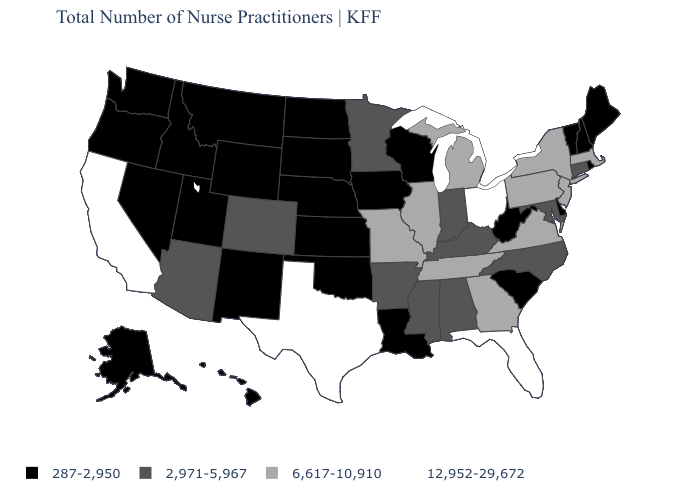What is the value of Indiana?
Short answer required. 2,971-5,967. Name the states that have a value in the range 12,952-29,672?
Be succinct. California, Florida, Ohio, Texas. What is the value of West Virginia?
Write a very short answer. 287-2,950. What is the value of Idaho?
Quick response, please. 287-2,950. Does Florida have the highest value in the USA?
Keep it brief. Yes. Is the legend a continuous bar?
Short answer required. No. Does the first symbol in the legend represent the smallest category?
Be succinct. Yes. Name the states that have a value in the range 287-2,950?
Quick response, please. Alaska, Delaware, Hawaii, Idaho, Iowa, Kansas, Louisiana, Maine, Montana, Nebraska, Nevada, New Hampshire, New Mexico, North Dakota, Oklahoma, Oregon, Rhode Island, South Carolina, South Dakota, Utah, Vermont, Washington, West Virginia, Wisconsin, Wyoming. What is the value of Texas?
Short answer required. 12,952-29,672. Does the map have missing data?
Concise answer only. No. What is the value of Nebraska?
Answer briefly. 287-2,950. What is the value of Maine?
Answer briefly. 287-2,950. What is the value of Oregon?
Keep it brief. 287-2,950. Is the legend a continuous bar?
Concise answer only. No. Which states have the highest value in the USA?
Quick response, please. California, Florida, Ohio, Texas. 